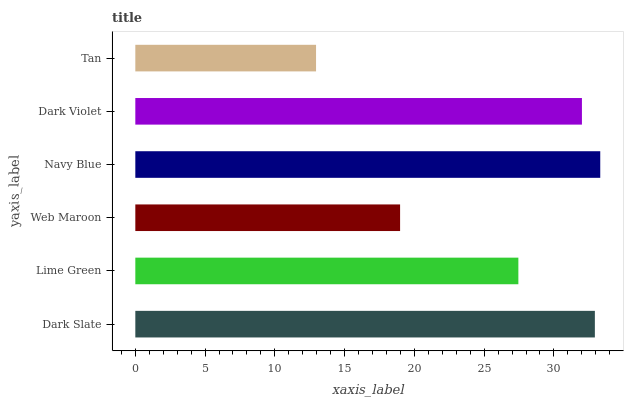Is Tan the minimum?
Answer yes or no. Yes. Is Navy Blue the maximum?
Answer yes or no. Yes. Is Lime Green the minimum?
Answer yes or no. No. Is Lime Green the maximum?
Answer yes or no. No. Is Dark Slate greater than Lime Green?
Answer yes or no. Yes. Is Lime Green less than Dark Slate?
Answer yes or no. Yes. Is Lime Green greater than Dark Slate?
Answer yes or no. No. Is Dark Slate less than Lime Green?
Answer yes or no. No. Is Dark Violet the high median?
Answer yes or no. Yes. Is Lime Green the low median?
Answer yes or no. Yes. Is Navy Blue the high median?
Answer yes or no. No. Is Web Maroon the low median?
Answer yes or no. No. 